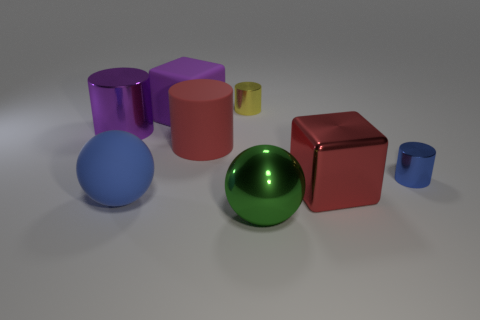Does the blue object that is to the right of the matte cylinder have the same shape as the large thing to the left of the blue rubber thing?
Offer a very short reply. Yes. Are there any red blocks made of the same material as the blue sphere?
Your response must be concise. No. What is the color of the shiny cube?
Give a very brief answer. Red. How big is the blue rubber sphere that is on the left side of the yellow metal cylinder?
Provide a succinct answer. Large. What number of things are the same color as the matte cube?
Offer a very short reply. 1. There is a large block left of the green object; are there any large cubes in front of it?
Provide a short and direct response. Yes. There is a cube that is to the left of the yellow shiny cylinder; is its color the same as the metallic cylinder that is on the left side of the purple cube?
Your response must be concise. Yes. The metal cube that is the same size as the purple metallic cylinder is what color?
Offer a very short reply. Red. Is the number of large purple cylinders in front of the large red cylinder the same as the number of large blue objects that are right of the metallic cube?
Ensure brevity in your answer.  Yes. There is a tiny object that is in front of the block behind the rubber cylinder; what is it made of?
Your answer should be very brief. Metal. 